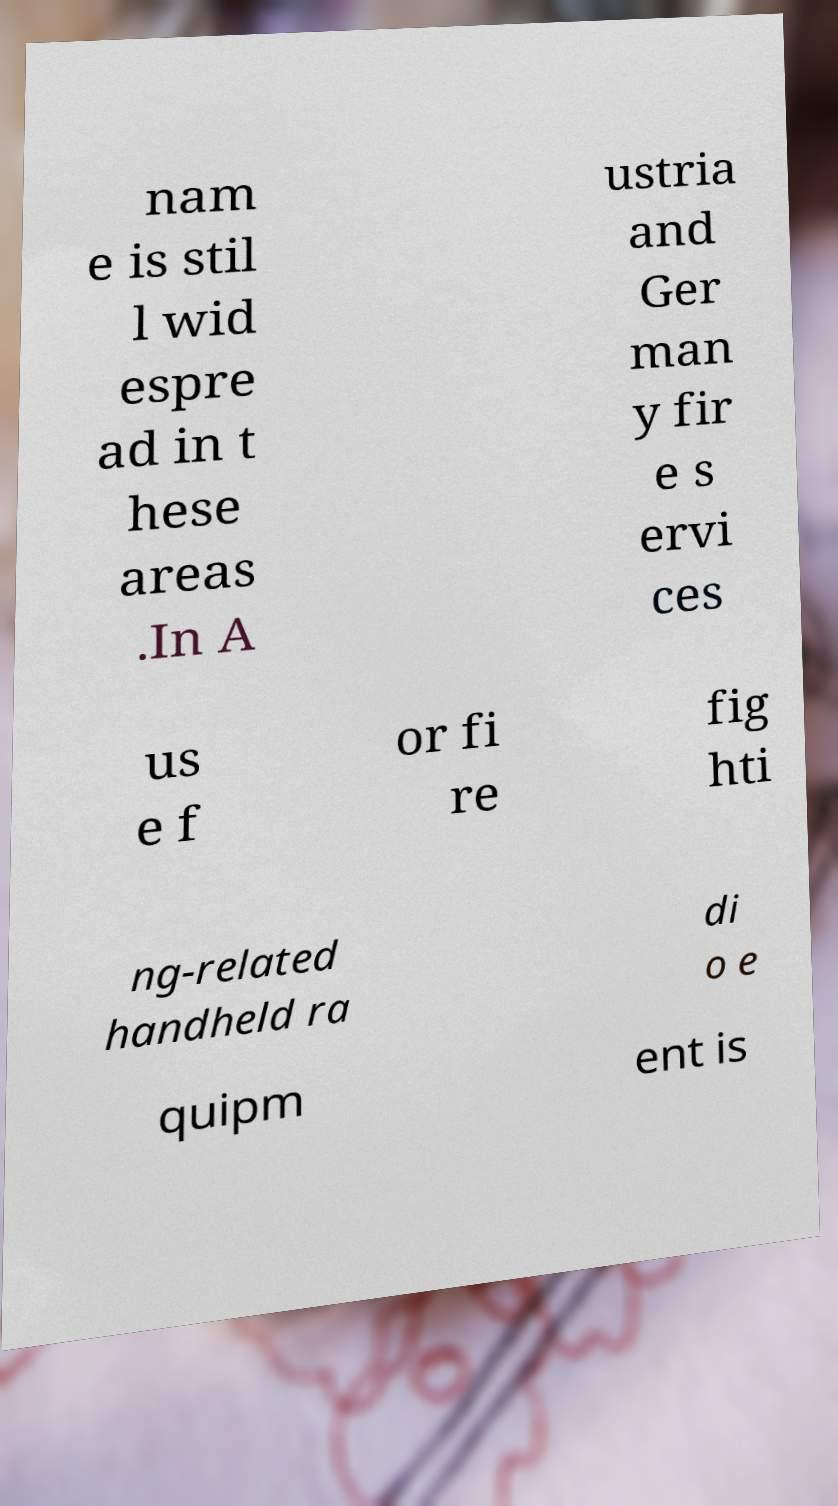I need the written content from this picture converted into text. Can you do that? nam e is stil l wid espre ad in t hese areas .In A ustria and Ger man y fir e s ervi ces us e f or fi re fig hti ng-related handheld ra di o e quipm ent is 